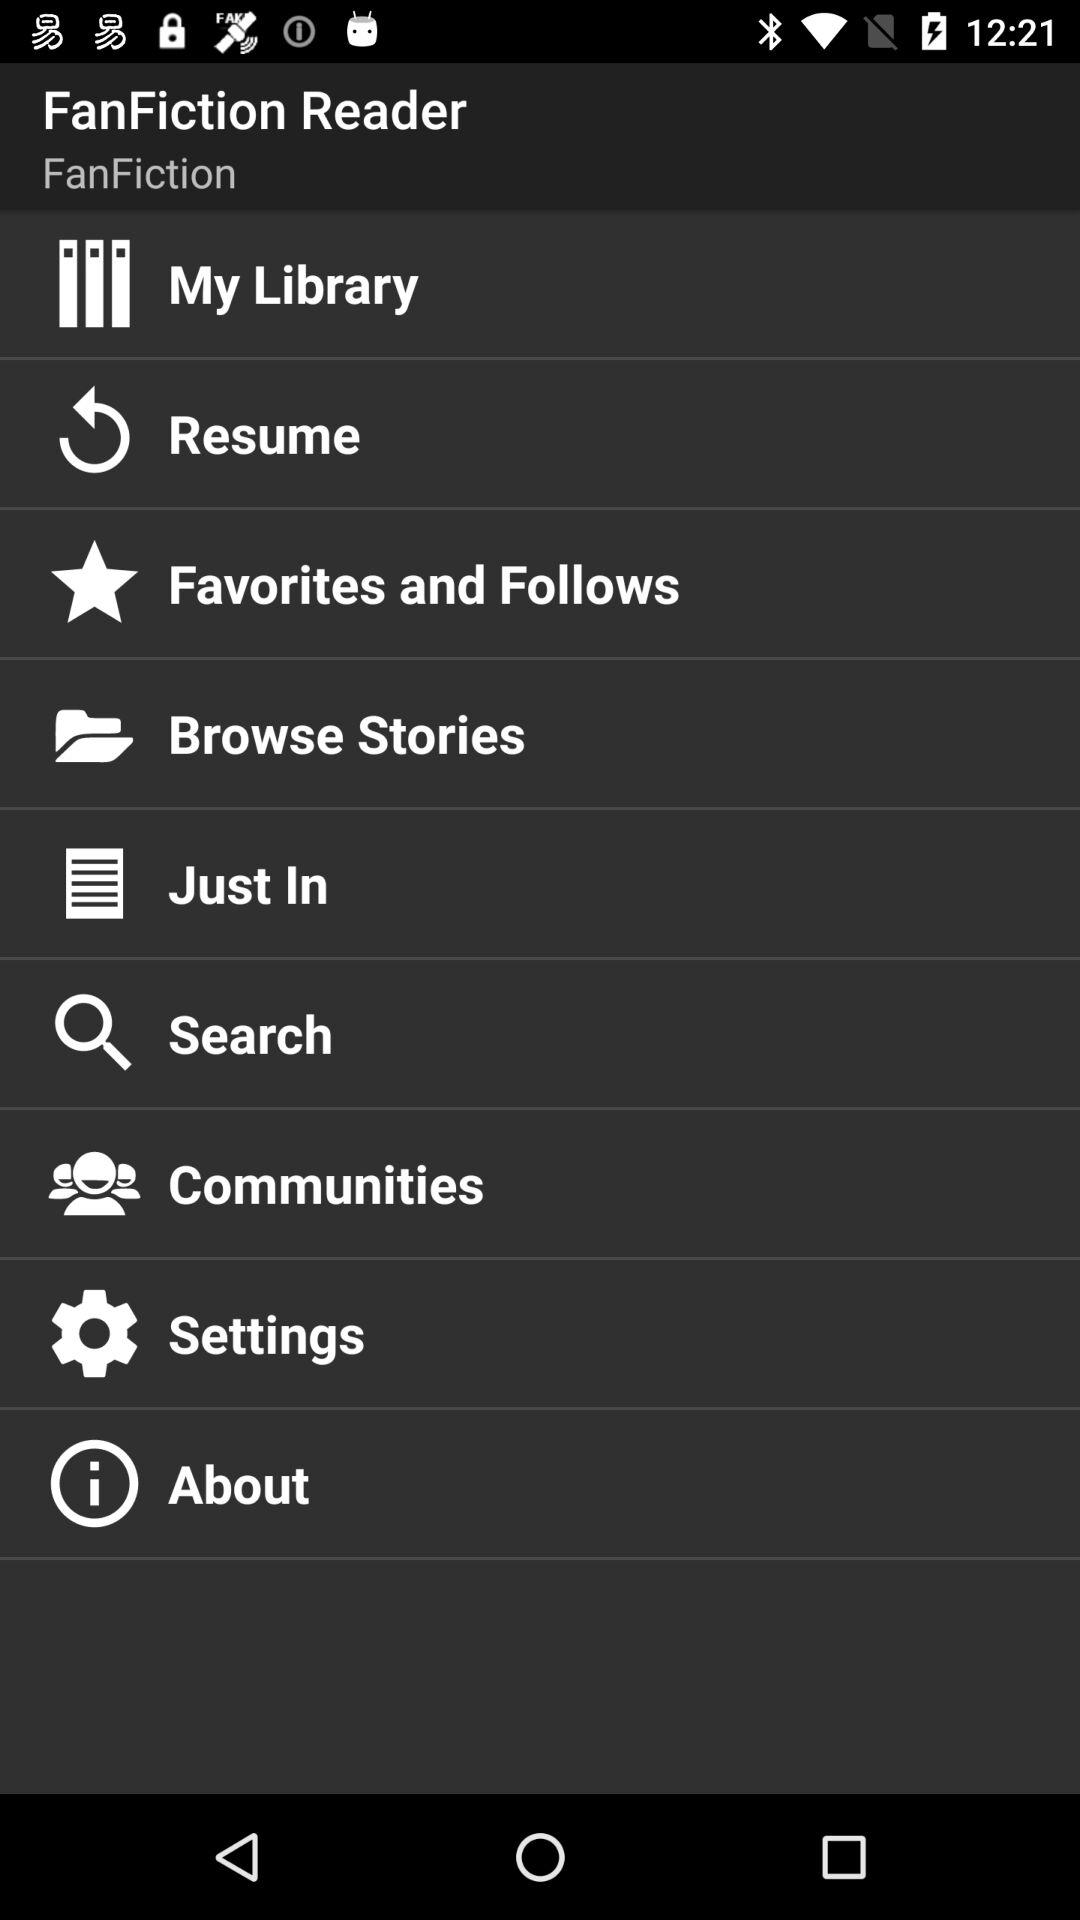What is the application name? The application name is "FanFiction Reader". 